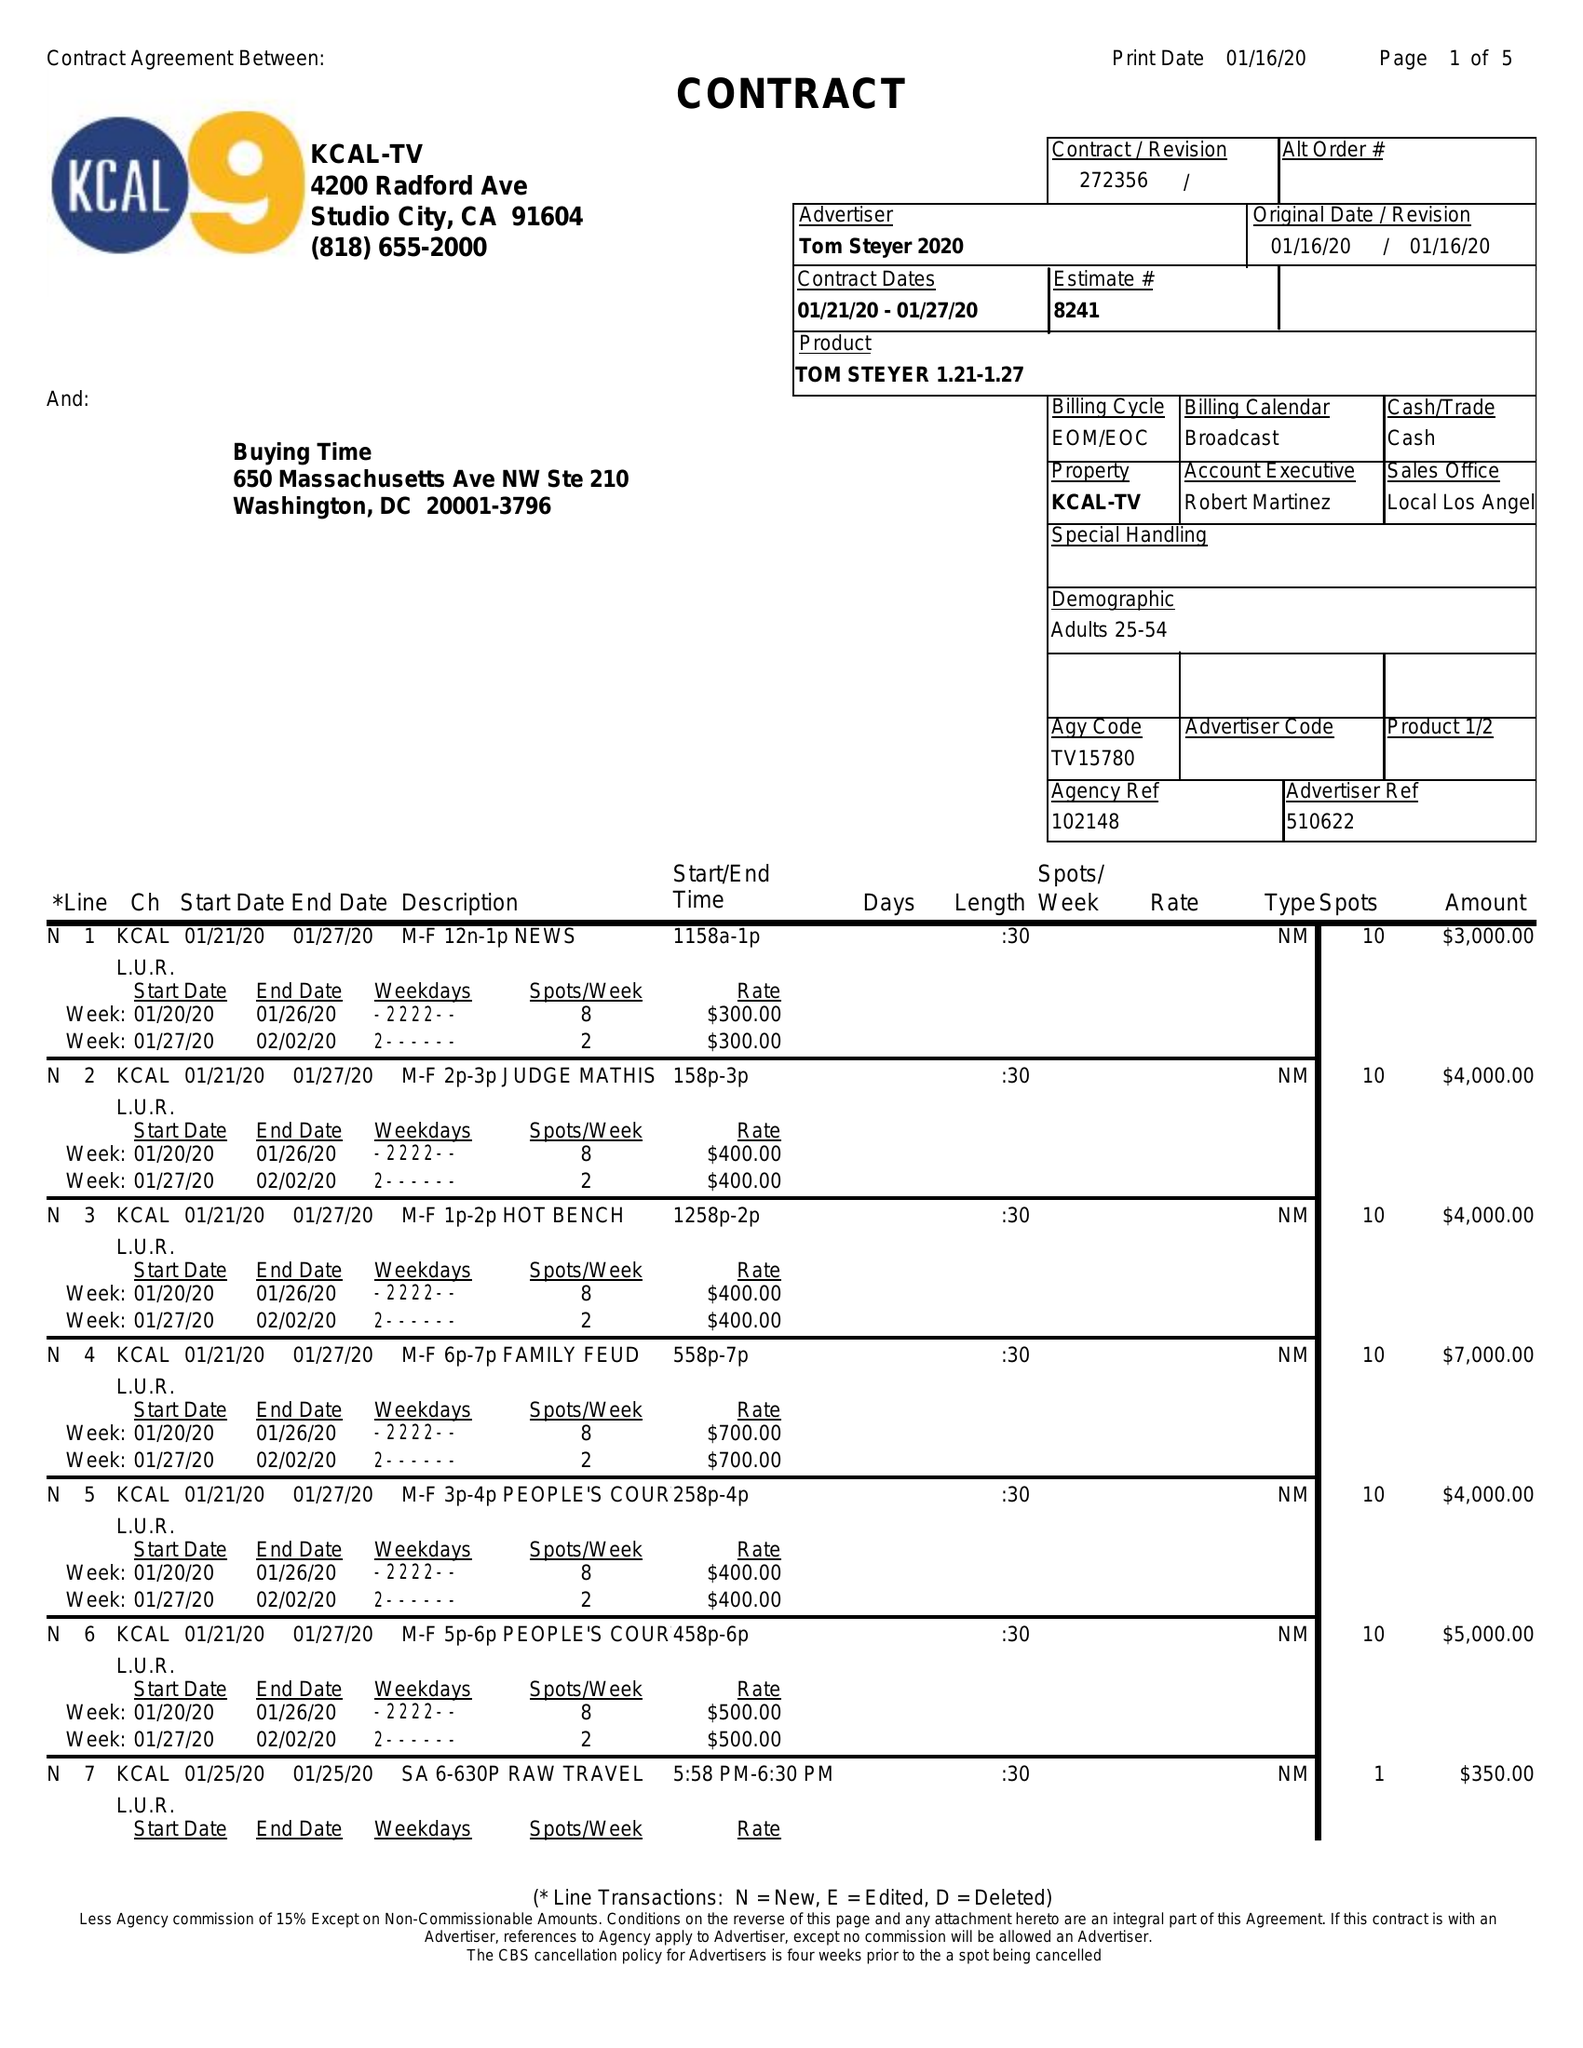What is the value for the gross_amount?
Answer the question using a single word or phrase. 88250.00 